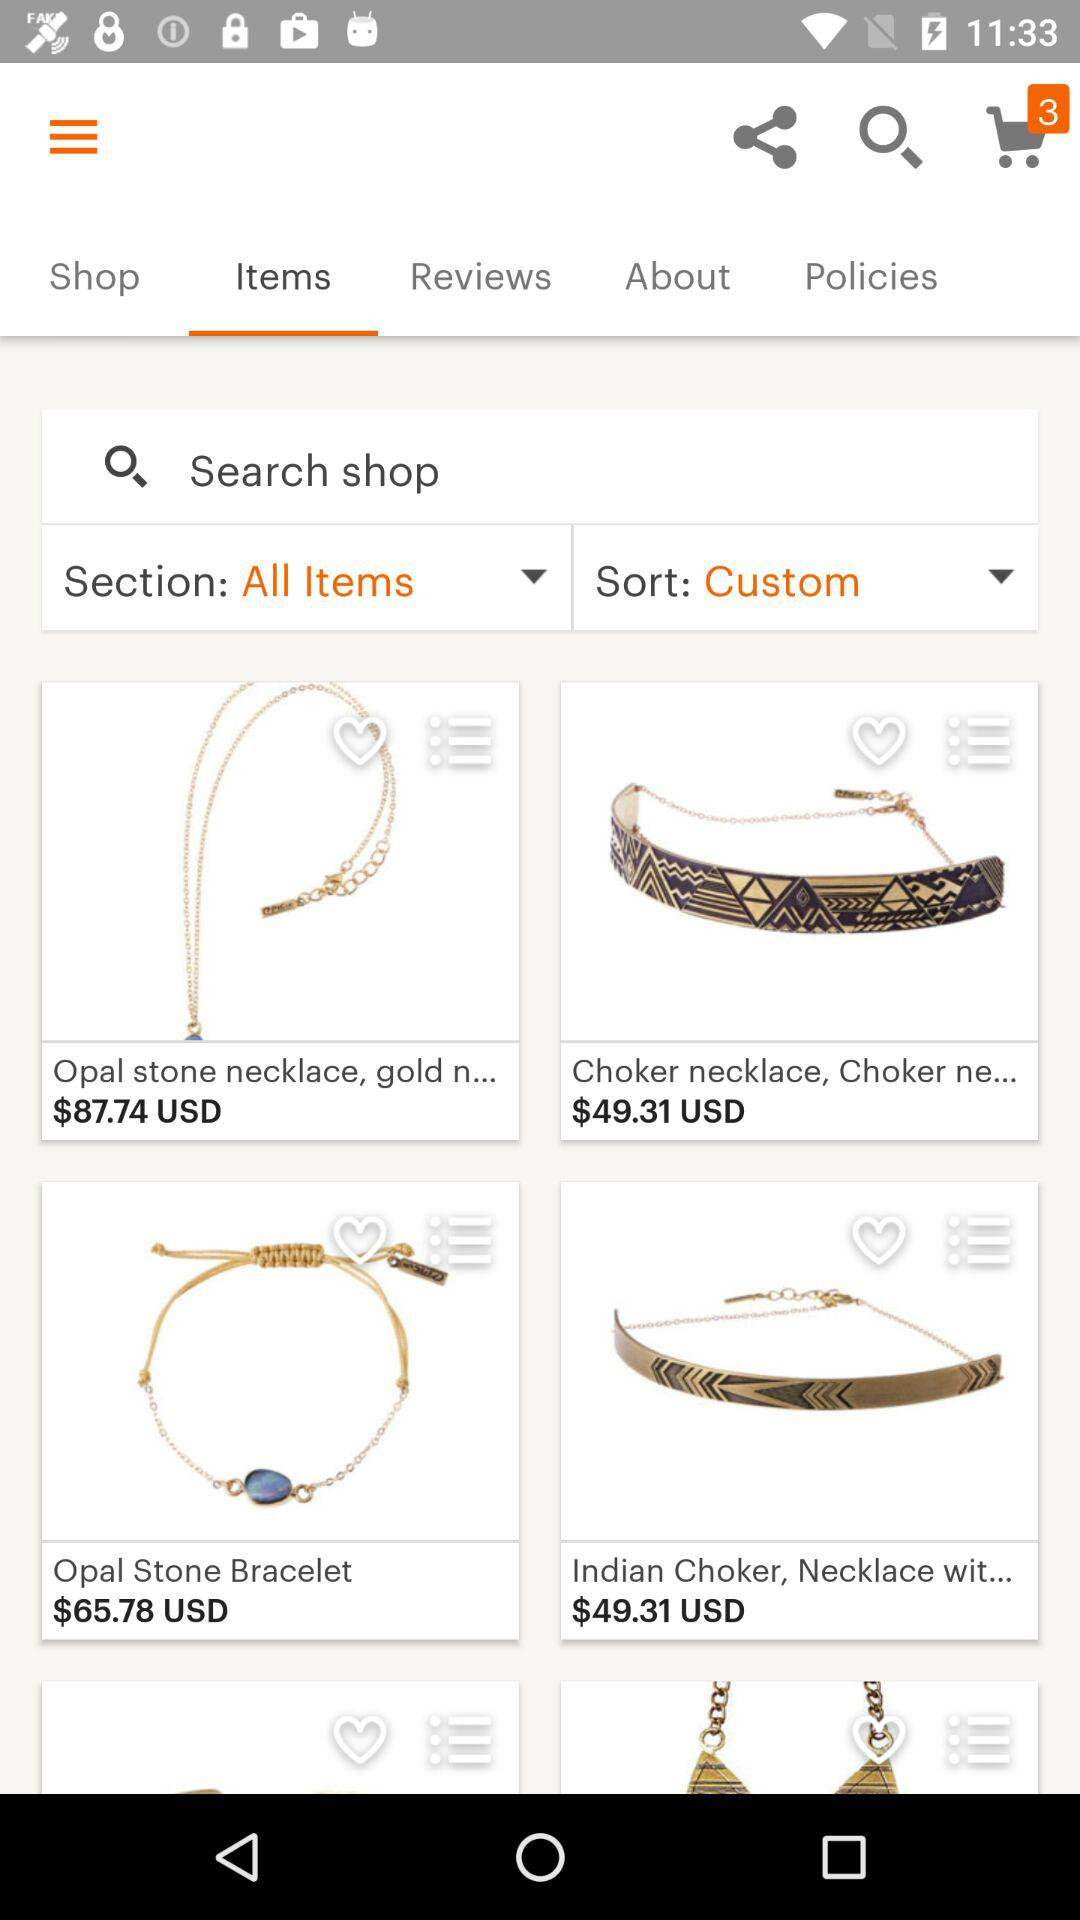Which tab is selected? The selected tab is "Items". 